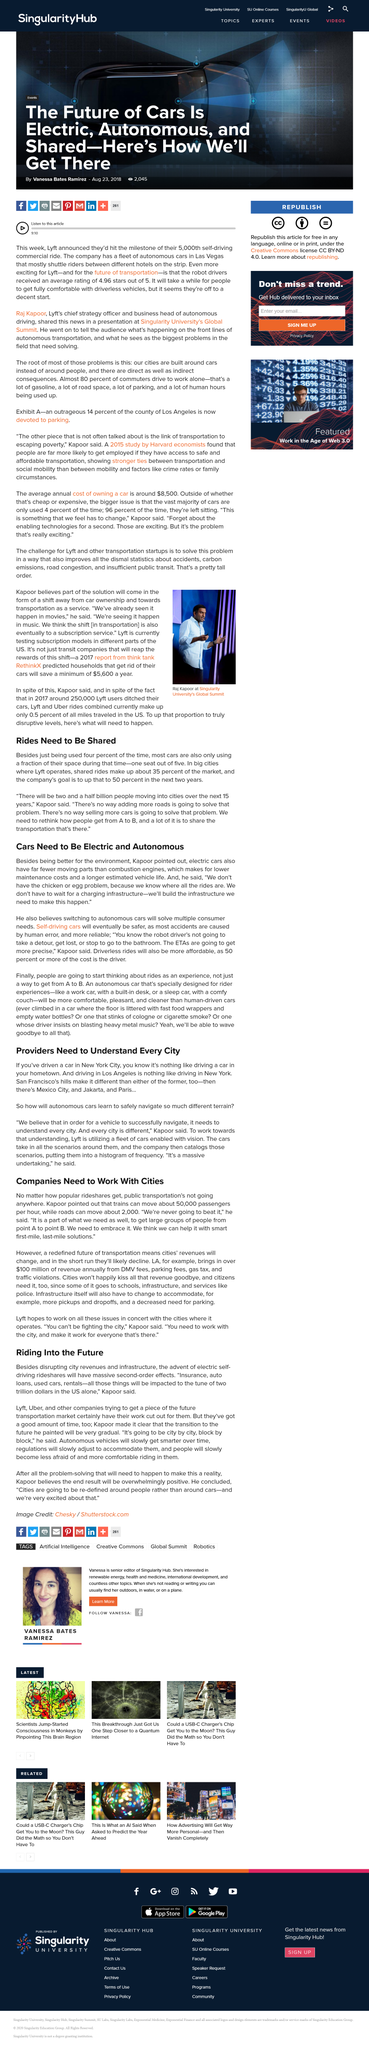Highlight a few significant elements in this photo. Self-driving cars will be safer than traditional cars because most accidents are caused by human error, as stated in the article. The fact that most cars are only using a fraction of their space when being driven is a reason why rides need to be shared. Yes, it is. Kapoor asserts that with the advent of electric and autonomous cars, there will be significantly lower maintenance costs and driverless rides will become more affordable. Most cars are used only a small percentage of the time, with a majority of them being used for less than 5% of the day. According to Kapoor, the charging infrastructure does not need to be built before the widespread adoption of electric buses, as it is not necessary to wait for a charging infrastructure to be built before implementing the use of electric buses, 